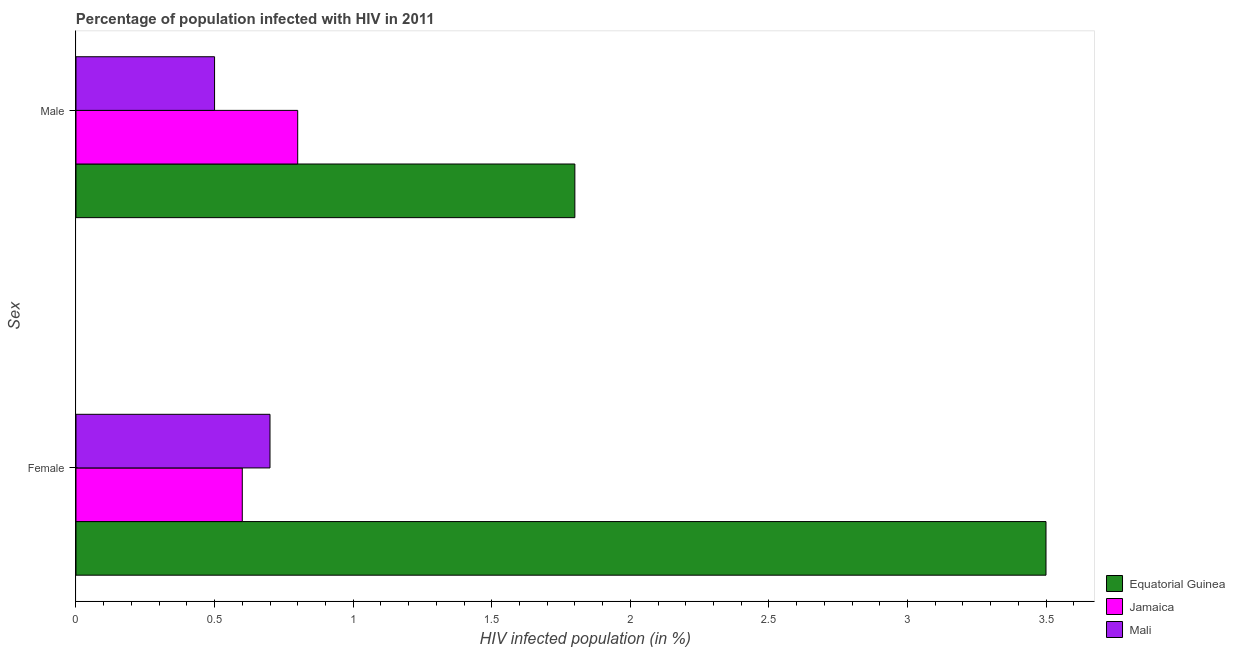How many groups of bars are there?
Make the answer very short. 2. How many bars are there on the 2nd tick from the top?
Offer a terse response. 3. How many bars are there on the 1st tick from the bottom?
Offer a terse response. 3. What is the label of the 2nd group of bars from the top?
Offer a very short reply. Female. What is the percentage of males who are infected with hiv in Equatorial Guinea?
Your answer should be compact. 1.8. Across all countries, what is the maximum percentage of females who are infected with hiv?
Provide a succinct answer. 3.5. Across all countries, what is the minimum percentage of males who are infected with hiv?
Provide a succinct answer. 0.5. In which country was the percentage of females who are infected with hiv maximum?
Keep it short and to the point. Equatorial Guinea. In which country was the percentage of males who are infected with hiv minimum?
Offer a very short reply. Mali. What is the difference between the percentage of males who are infected with hiv in Mali and that in Jamaica?
Make the answer very short. -0.3. What is the difference between the percentage of males who are infected with hiv in Jamaica and the percentage of females who are infected with hiv in Mali?
Offer a very short reply. 0.1. What is the average percentage of females who are infected with hiv per country?
Ensure brevity in your answer.  1.6. What is the difference between the percentage of males who are infected with hiv and percentage of females who are infected with hiv in Jamaica?
Your answer should be very brief. 0.2. In how many countries, is the percentage of females who are infected with hiv greater than 3.2 %?
Your response must be concise. 1. What is the ratio of the percentage of females who are infected with hiv in Equatorial Guinea to that in Mali?
Keep it short and to the point. 5. In how many countries, is the percentage of females who are infected with hiv greater than the average percentage of females who are infected with hiv taken over all countries?
Your answer should be very brief. 1. What does the 2nd bar from the top in Female represents?
Offer a terse response. Jamaica. What does the 2nd bar from the bottom in Female represents?
Provide a succinct answer. Jamaica. Are all the bars in the graph horizontal?
Offer a terse response. Yes. How many countries are there in the graph?
Your response must be concise. 3. What is the difference between two consecutive major ticks on the X-axis?
Offer a very short reply. 0.5. Does the graph contain any zero values?
Provide a succinct answer. No. How are the legend labels stacked?
Keep it short and to the point. Vertical. What is the title of the graph?
Your answer should be very brief. Percentage of population infected with HIV in 2011. What is the label or title of the X-axis?
Your answer should be very brief. HIV infected population (in %). What is the label or title of the Y-axis?
Offer a terse response. Sex. What is the HIV infected population (in %) in Jamaica in Female?
Your answer should be very brief. 0.6. What is the HIV infected population (in %) of Mali in Female?
Offer a terse response. 0.7. Across all Sex, what is the maximum HIV infected population (in %) of Equatorial Guinea?
Provide a succinct answer. 3.5. Across all Sex, what is the maximum HIV infected population (in %) in Mali?
Provide a short and direct response. 0.7. Across all Sex, what is the minimum HIV infected population (in %) of Mali?
Make the answer very short. 0.5. What is the total HIV infected population (in %) of Jamaica in the graph?
Give a very brief answer. 1.4. What is the difference between the HIV infected population (in %) in Equatorial Guinea in Female and that in Male?
Offer a terse response. 1.7. What is the difference between the HIV infected population (in %) of Mali in Female and that in Male?
Keep it short and to the point. 0.2. What is the difference between the HIV infected population (in %) in Equatorial Guinea in Female and the HIV infected population (in %) in Jamaica in Male?
Make the answer very short. 2.7. What is the difference between the HIV infected population (in %) of Equatorial Guinea in Female and the HIV infected population (in %) of Mali in Male?
Offer a terse response. 3. What is the difference between the HIV infected population (in %) in Jamaica in Female and the HIV infected population (in %) in Mali in Male?
Ensure brevity in your answer.  0.1. What is the average HIV infected population (in %) of Equatorial Guinea per Sex?
Your response must be concise. 2.65. What is the difference between the HIV infected population (in %) in Equatorial Guinea and HIV infected population (in %) in Mali in Female?
Offer a very short reply. 2.8. What is the difference between the HIV infected population (in %) of Equatorial Guinea and HIV infected population (in %) of Jamaica in Male?
Make the answer very short. 1. What is the difference between the HIV infected population (in %) in Equatorial Guinea and HIV infected population (in %) in Mali in Male?
Your answer should be very brief. 1.3. What is the ratio of the HIV infected population (in %) of Equatorial Guinea in Female to that in Male?
Make the answer very short. 1.94. What is the ratio of the HIV infected population (in %) of Jamaica in Female to that in Male?
Your response must be concise. 0.75. What is the difference between the highest and the second highest HIV infected population (in %) of Jamaica?
Your response must be concise. 0.2. What is the difference between the highest and the second highest HIV infected population (in %) of Mali?
Ensure brevity in your answer.  0.2. What is the difference between the highest and the lowest HIV infected population (in %) in Mali?
Give a very brief answer. 0.2. 